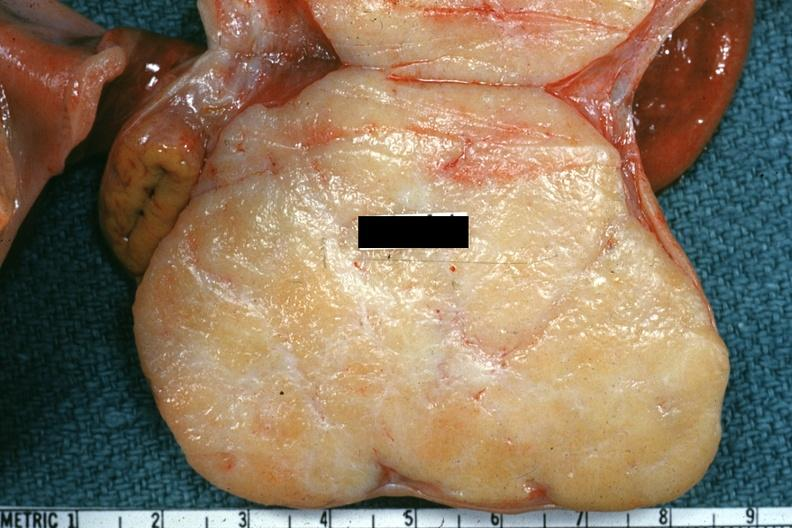does band constriction in skin above ankle of infant show excellent example of brenner tumor?
Answer the question using a single word or phrase. No 